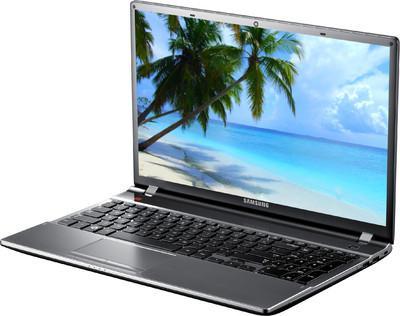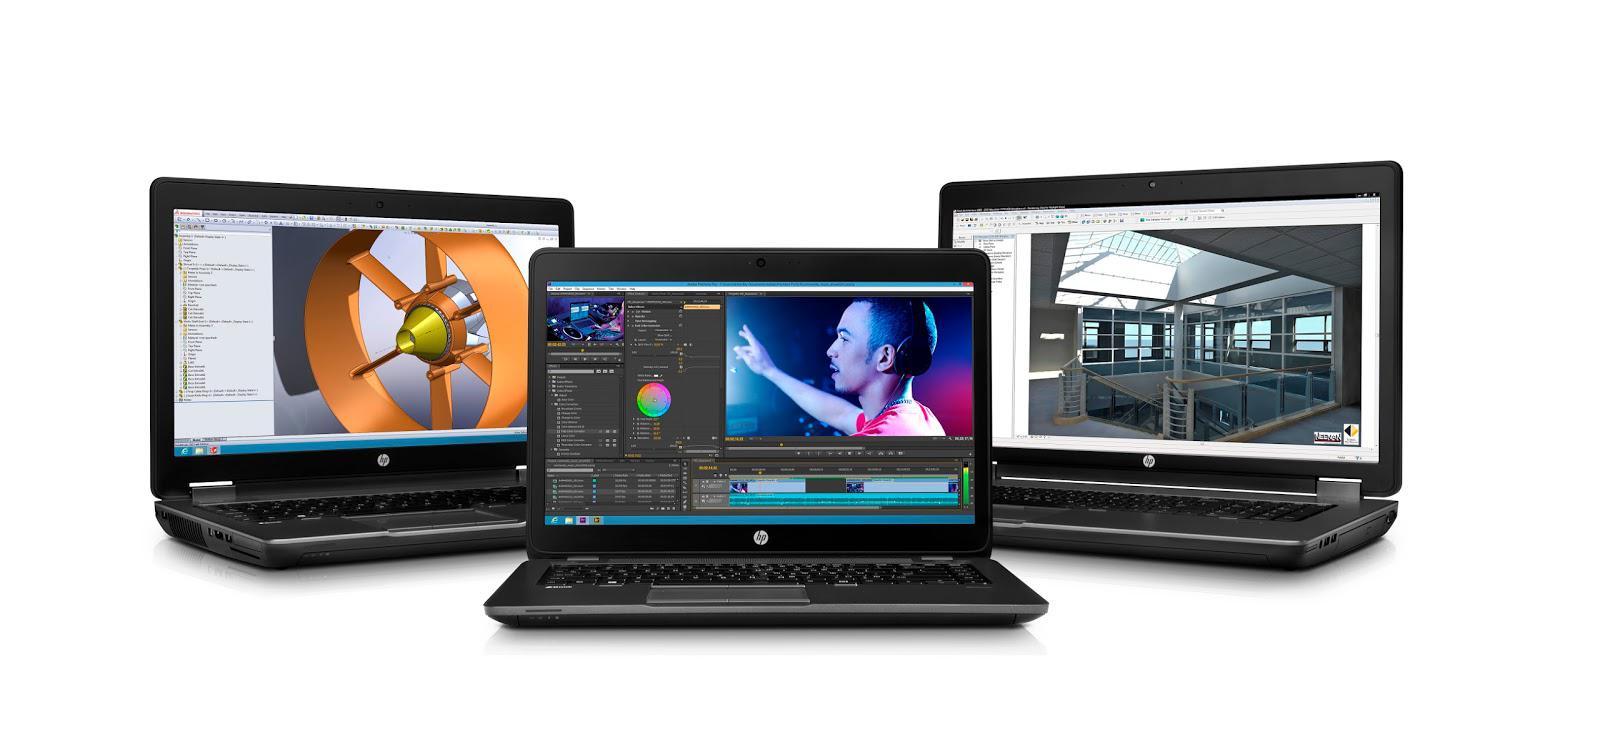The first image is the image on the left, the second image is the image on the right. For the images displayed, is the sentence "Three open laptops with imagery on the screens are displayed horizontally in one picture." factually correct? Answer yes or no. Yes. The first image is the image on the left, the second image is the image on the right. Assess this claim about the two images: "There are three grouped laptops in the image on the right.". Correct or not? Answer yes or no. Yes. 